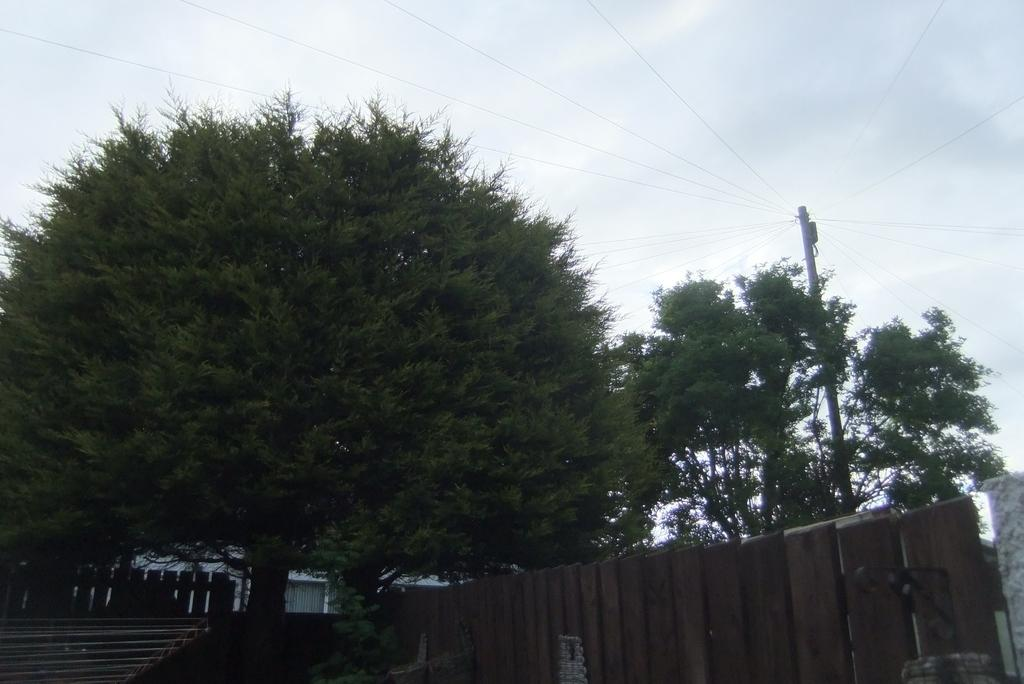What type of structure is present in the image? There is a building in the image. What feature of the building is mentioned in the facts? The building has stairs. What other objects can be seen in the image? There is a fence, trees, a wall, and a current pole in the image. What part of the natural environment is visible in the image? The sky is visible in the image. Who is the creator of the mist in the image? There is no mist present in the image, so there is no creator for it. 